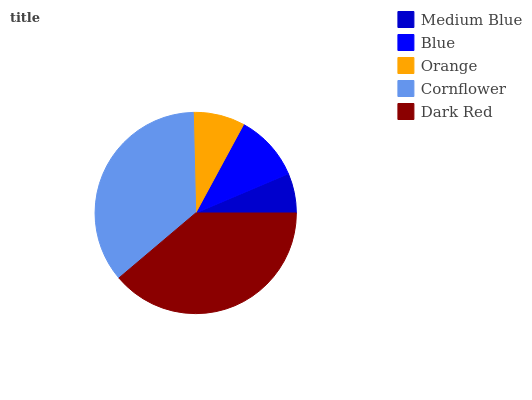Is Medium Blue the minimum?
Answer yes or no. Yes. Is Dark Red the maximum?
Answer yes or no. Yes. Is Blue the minimum?
Answer yes or no. No. Is Blue the maximum?
Answer yes or no. No. Is Blue greater than Medium Blue?
Answer yes or no. Yes. Is Medium Blue less than Blue?
Answer yes or no. Yes. Is Medium Blue greater than Blue?
Answer yes or no. No. Is Blue less than Medium Blue?
Answer yes or no. No. Is Blue the high median?
Answer yes or no. Yes. Is Blue the low median?
Answer yes or no. Yes. Is Dark Red the high median?
Answer yes or no. No. Is Orange the low median?
Answer yes or no. No. 